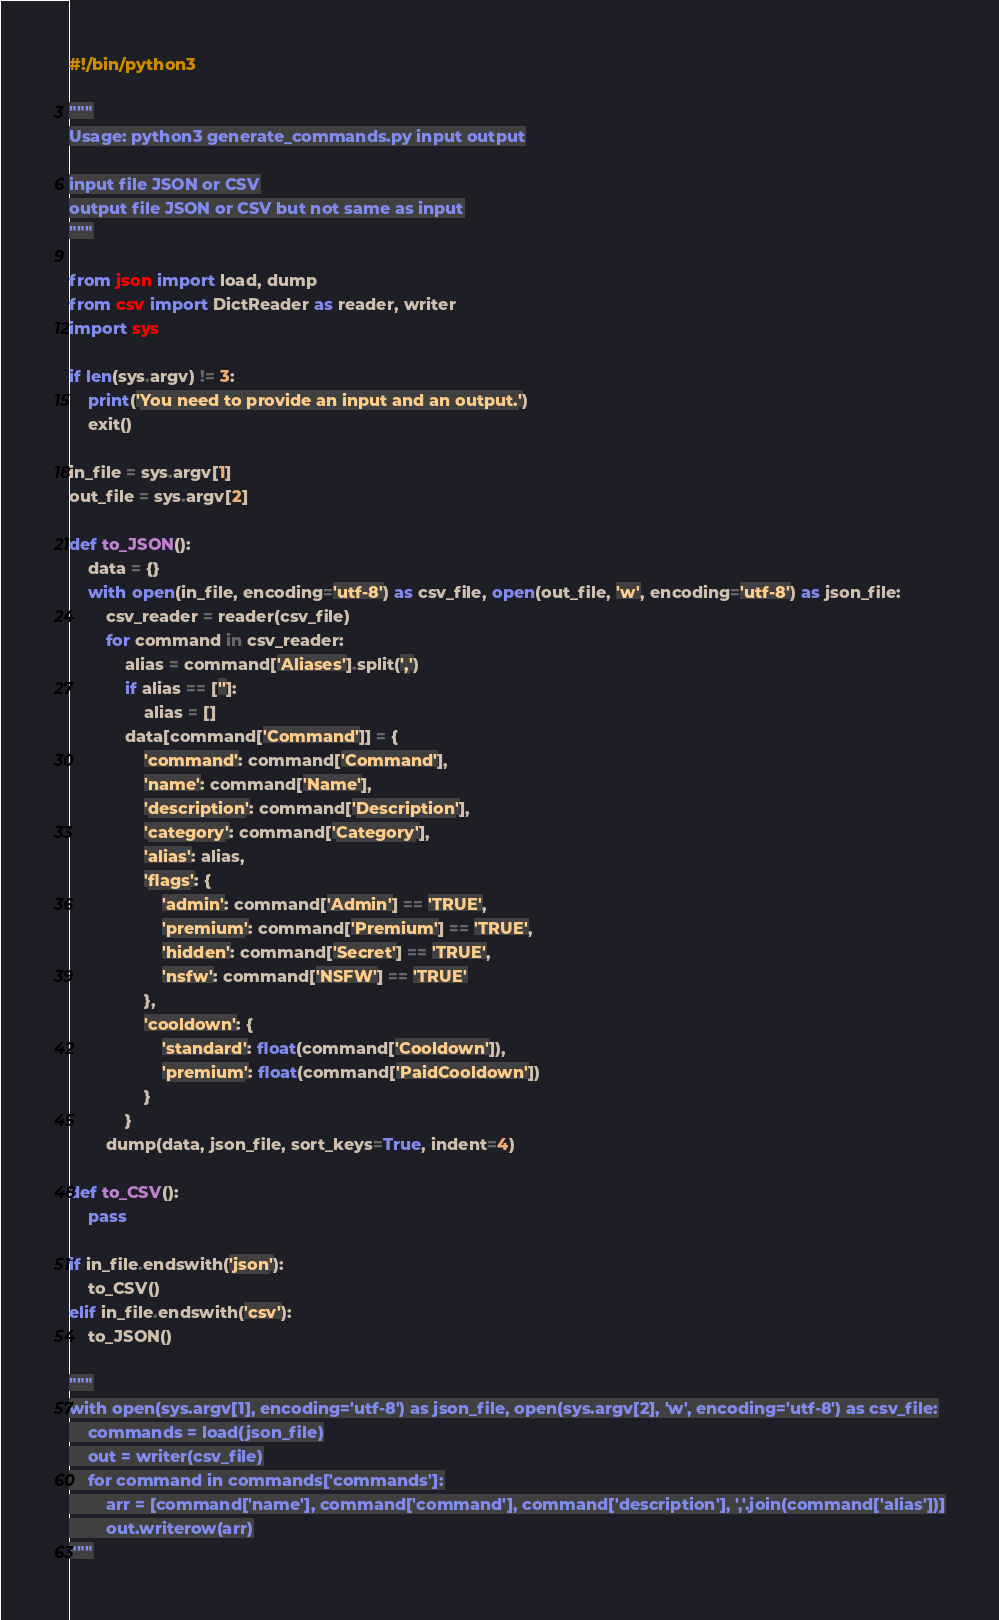<code> <loc_0><loc_0><loc_500><loc_500><_Python_>#!/bin/python3

"""
Usage: python3 generate_commands.py input output

input file JSON or CSV
output file JSON or CSV but not same as input
"""

from json import load, dump
from csv import DictReader as reader, writer
import sys

if len(sys.argv) != 3:
    print('You need to provide an input and an output.')
    exit()

in_file = sys.argv[1]
out_file = sys.argv[2]

def to_JSON():
    data = {}
    with open(in_file, encoding='utf-8') as csv_file, open(out_file, 'w', encoding='utf-8') as json_file:
        csv_reader = reader(csv_file)
        for command in csv_reader:
            alias = command['Aliases'].split(',')
            if alias == ['']:
                alias = []
            data[command['Command']] = {
                'command': command['Command'],
                'name': command['Name'],
                'description': command['Description'],
                'category': command['Category'],
                'alias': alias,
                'flags': {
                    'admin': command['Admin'] == 'TRUE',
                    'premium': command['Premium'] == 'TRUE',
                    'hidden': command['Secret'] == 'TRUE',
                    'nsfw': command['NSFW'] == 'TRUE'
                },
                'cooldown': {
                    'standard': float(command['Cooldown']),
                    'premium': float(command['PaidCooldown'])
                }
            }
        dump(data, json_file, sort_keys=True, indent=4)

def to_CSV():
    pass

if in_file.endswith('json'):
    to_CSV()
elif in_file.endswith('csv'):
    to_JSON()

"""
with open(sys.argv[1], encoding='utf-8') as json_file, open(sys.argv[2], 'w', encoding='utf-8') as csv_file:
    commands = load(json_file)
    out = writer(csv_file)
    for command in commands['commands']:
        arr = [command['name'], command['command'], command['description'], ','.join(command['alias'])]
        out.writerow(arr)
"""</code> 